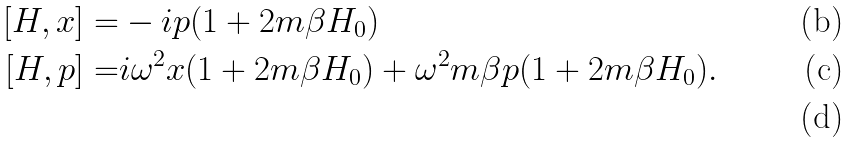Convert formula to latex. <formula><loc_0><loc_0><loc_500><loc_500>[ H , x ] = & - i p ( 1 + 2 m \beta H _ { 0 } ) \\ [ H , p ] = & i \omega ^ { 2 } x ( 1 + 2 m \beta H _ { 0 } ) + \omega ^ { 2 } m \beta p ( 1 + 2 m \beta H _ { 0 } ) . \\</formula> 